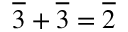<formula> <loc_0><loc_0><loc_500><loc_500>{ \overline { 3 } } + { \overline { 3 } } = { \overline { 2 } }</formula> 